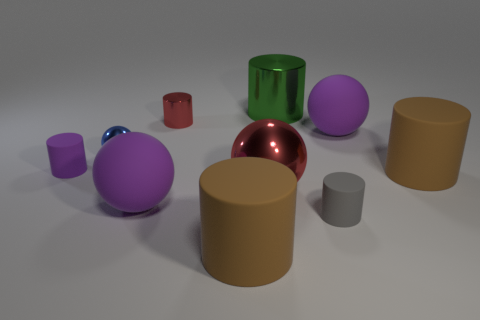What material is the object that is the same color as the small metal cylinder?
Keep it short and to the point. Metal. What number of tiny blue metal spheres are left of the big brown object in front of the large purple sphere that is on the left side of the gray rubber thing?
Provide a short and direct response. 1. There is a small blue metallic thing; what number of rubber things are to the left of it?
Make the answer very short. 1. There is a small object that is the same shape as the big red metallic object; what color is it?
Provide a short and direct response. Blue. What material is the ball that is on the left side of the green shiny cylinder and behind the large red thing?
Keep it short and to the point. Metal. There is a rubber ball that is behind the blue metal thing; is its size the same as the large red shiny thing?
Provide a short and direct response. Yes. What is the tiny sphere made of?
Make the answer very short. Metal. There is a big ball that is in front of the red sphere; what is its color?
Ensure brevity in your answer.  Purple. What number of small objects are either red objects or red metal cylinders?
Provide a short and direct response. 1. There is a big rubber cylinder left of the green cylinder; does it have the same color as the tiny rubber object that is on the right side of the purple rubber cylinder?
Make the answer very short. No. 